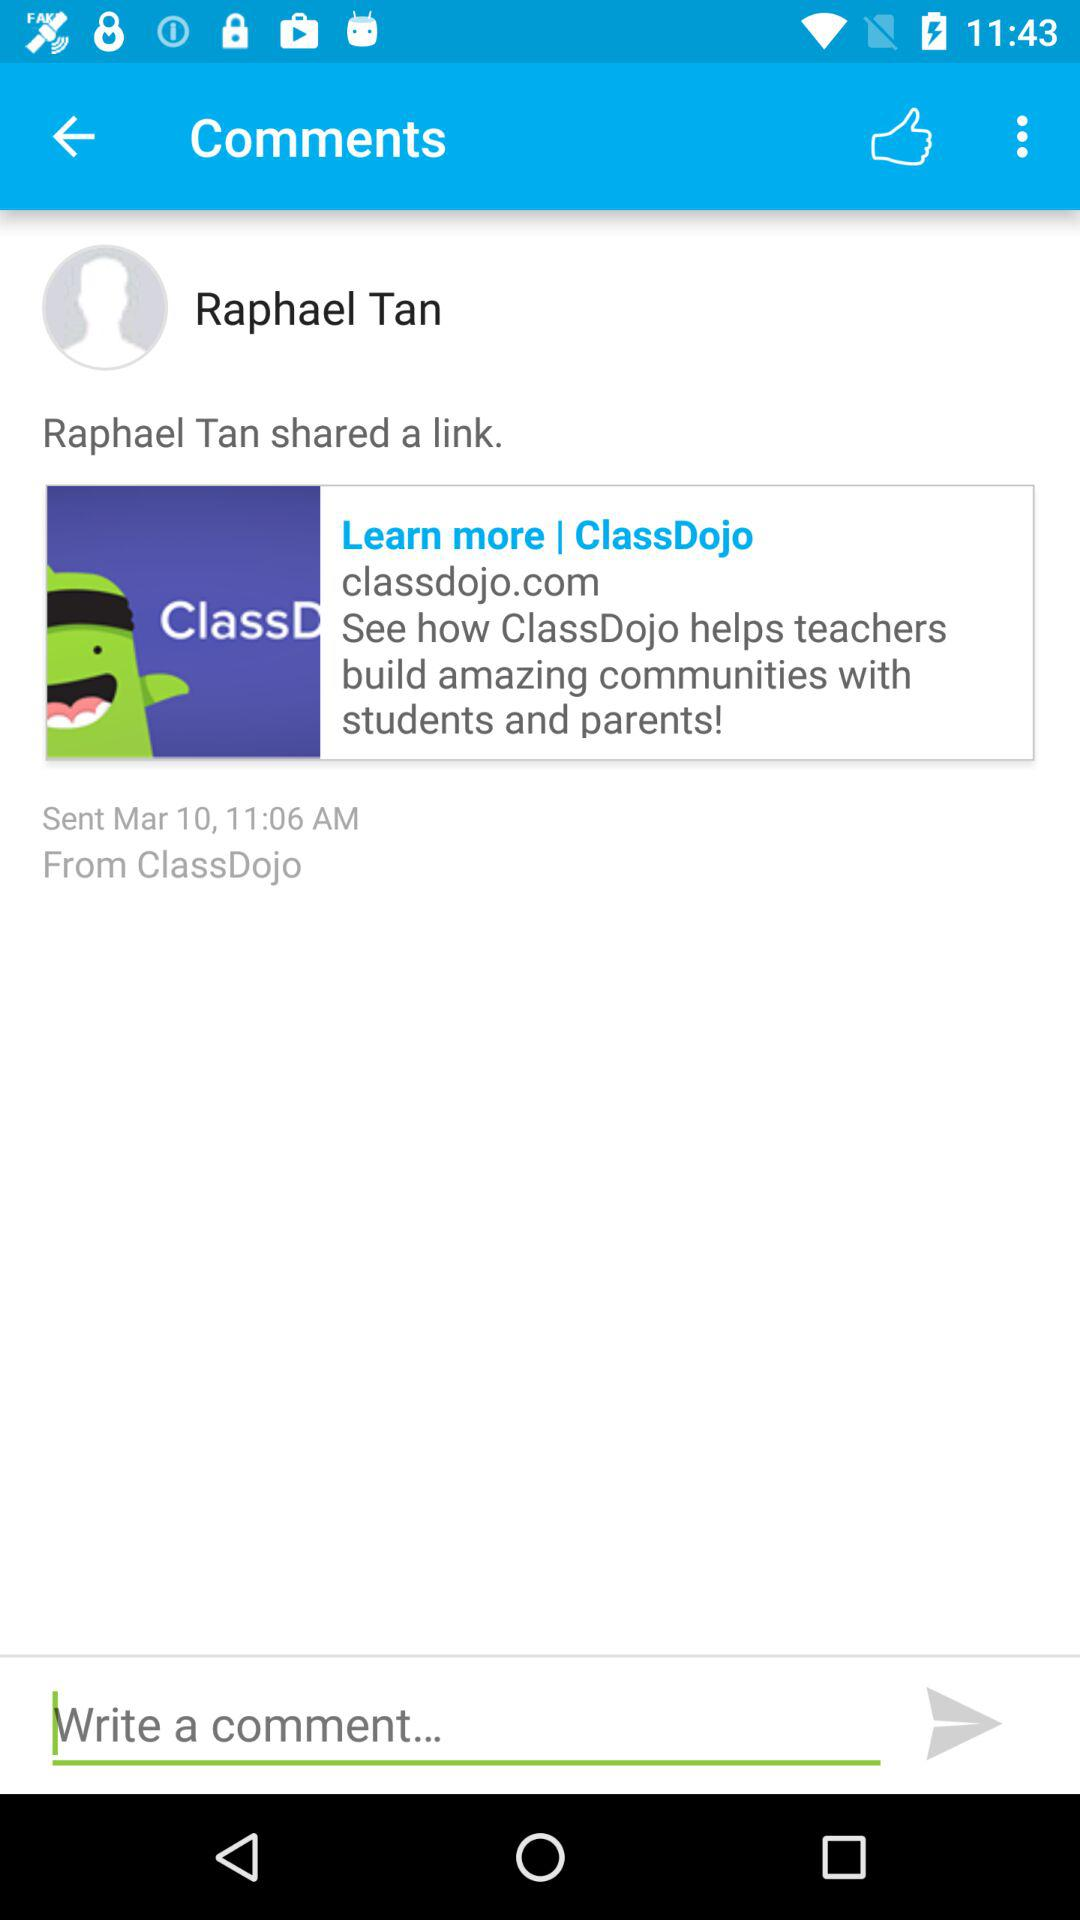On what date was the link shared? The link was shared on March 10. 